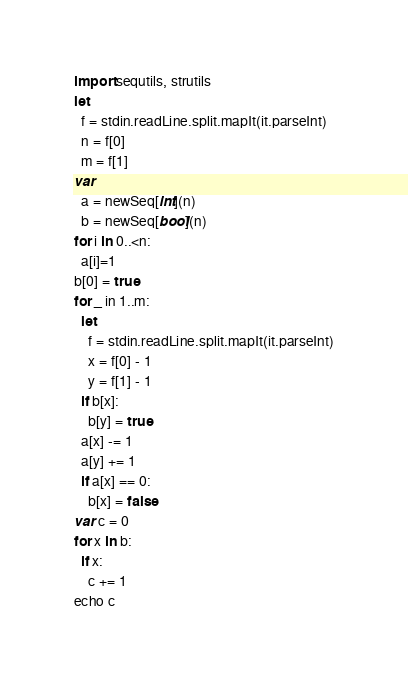Convert code to text. <code><loc_0><loc_0><loc_500><loc_500><_Nim_>import sequtils, strutils
let
  f = stdin.readLine.split.mapIt(it.parseInt)
  n = f[0]
  m = f[1]
var
  a = newSeq[int](n)
  b = newSeq[bool](n)
for i in 0..<n:
  a[i]=1
b[0] = true
for _ in 1..m:
  let
    f = stdin.readLine.split.mapIt(it.parseInt)
    x = f[0] - 1
    y = f[1] - 1
  if b[x]:
    b[y] = true
  a[x] -= 1
  a[y] += 1
  if a[x] == 0:
    b[x] = false
var c = 0
for x in b:
  if x:
    c += 1
echo c
</code> 